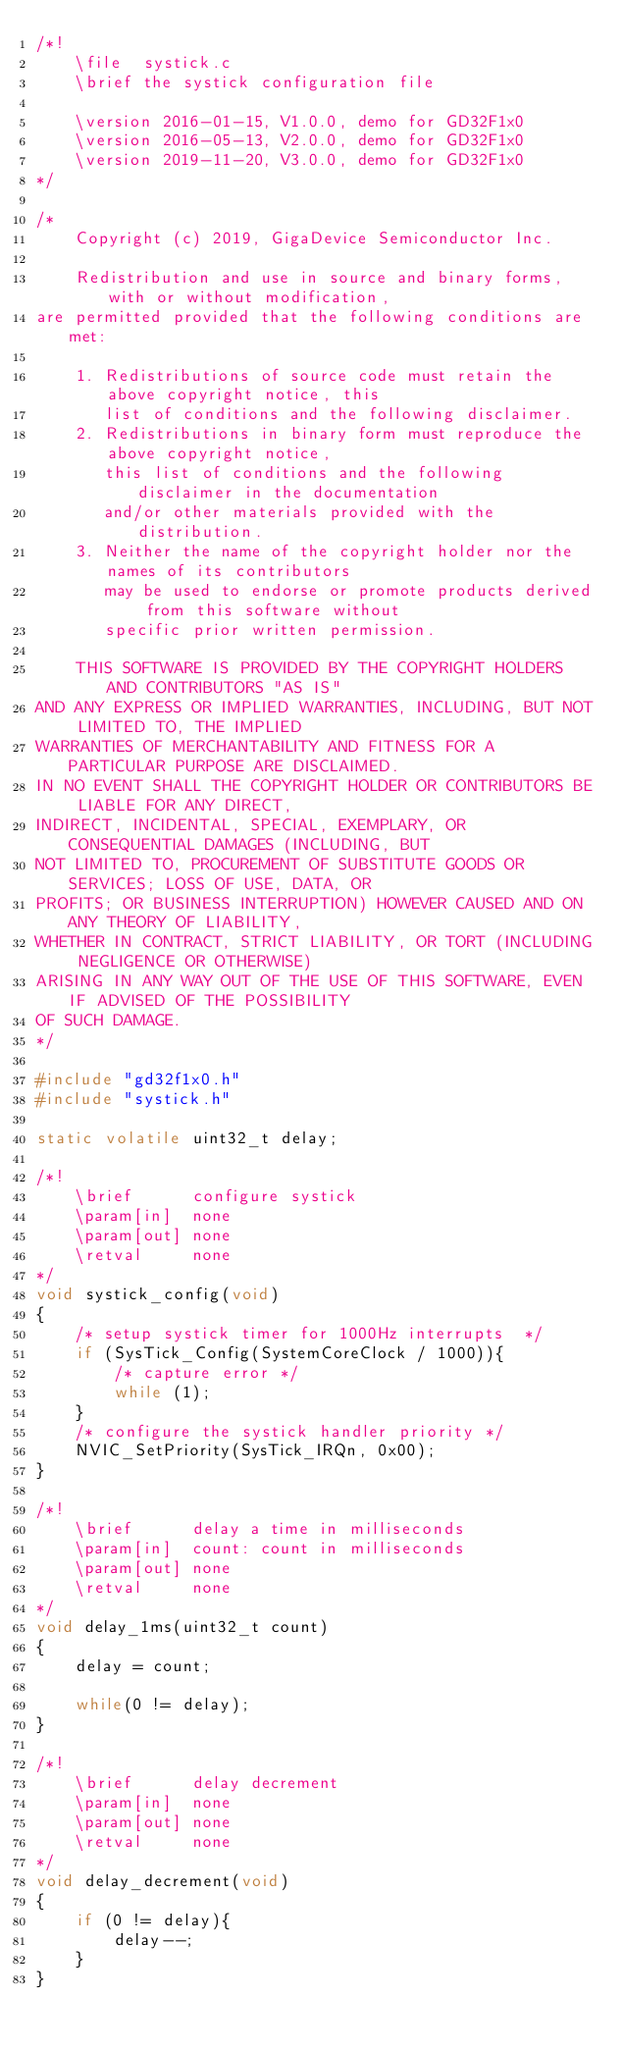<code> <loc_0><loc_0><loc_500><loc_500><_C_>/*!
    \file  systick.c
    \brief the systick configuration file

    \version 2016-01-15, V1.0.0, demo for GD32F1x0
    \version 2016-05-13, V2.0.0, demo for GD32F1x0
    \version 2019-11-20, V3.0.0, demo for GD32F1x0
*/

/*
    Copyright (c) 2019, GigaDevice Semiconductor Inc.

    Redistribution and use in source and binary forms, with or without modification, 
are permitted provided that the following conditions are met:

    1. Redistributions of source code must retain the above copyright notice, this 
       list of conditions and the following disclaimer.
    2. Redistributions in binary form must reproduce the above copyright notice, 
       this list of conditions and the following disclaimer in the documentation 
       and/or other materials provided with the distribution.
    3. Neither the name of the copyright holder nor the names of its contributors 
       may be used to endorse or promote products derived from this software without 
       specific prior written permission.

    THIS SOFTWARE IS PROVIDED BY THE COPYRIGHT HOLDERS AND CONTRIBUTORS "AS IS" 
AND ANY EXPRESS OR IMPLIED WARRANTIES, INCLUDING, BUT NOT LIMITED TO, THE IMPLIED 
WARRANTIES OF MERCHANTABILITY AND FITNESS FOR A PARTICULAR PURPOSE ARE DISCLAIMED. 
IN NO EVENT SHALL THE COPYRIGHT HOLDER OR CONTRIBUTORS BE LIABLE FOR ANY DIRECT, 
INDIRECT, INCIDENTAL, SPECIAL, EXEMPLARY, OR CONSEQUENTIAL DAMAGES (INCLUDING, BUT 
NOT LIMITED TO, PROCUREMENT OF SUBSTITUTE GOODS OR SERVICES; LOSS OF USE, DATA, OR 
PROFITS; OR BUSINESS INTERRUPTION) HOWEVER CAUSED AND ON ANY THEORY OF LIABILITY, 
WHETHER IN CONTRACT, STRICT LIABILITY, OR TORT (INCLUDING NEGLIGENCE OR OTHERWISE) 
ARISING IN ANY WAY OUT OF THE USE OF THIS SOFTWARE, EVEN IF ADVISED OF THE POSSIBILITY 
OF SUCH DAMAGE.
*/

#include "gd32f1x0.h"
#include "systick.h"

static volatile uint32_t delay;

/*!
    \brief      configure systick
    \param[in]  none
    \param[out] none
    \retval     none
*/
void systick_config(void)
{
    /* setup systick timer for 1000Hz interrupts  */
    if (SysTick_Config(SystemCoreClock / 1000)){
        /* capture error */
        while (1);
    }
    /* configure the systick handler priority */
    NVIC_SetPriority(SysTick_IRQn, 0x00);
}

/*!
    \brief      delay a time in milliseconds
    \param[in]  count: count in milliseconds
    \param[out] none
    \retval     none
*/
void delay_1ms(uint32_t count)
{
    delay = count;

    while(0 != delay);
}

/*!
    \brief      delay decrement
    \param[in]  none
    \param[out] none
    \retval     none
*/
void delay_decrement(void)
{
    if (0 != delay){ 
        delay--;
    }
}
</code> 